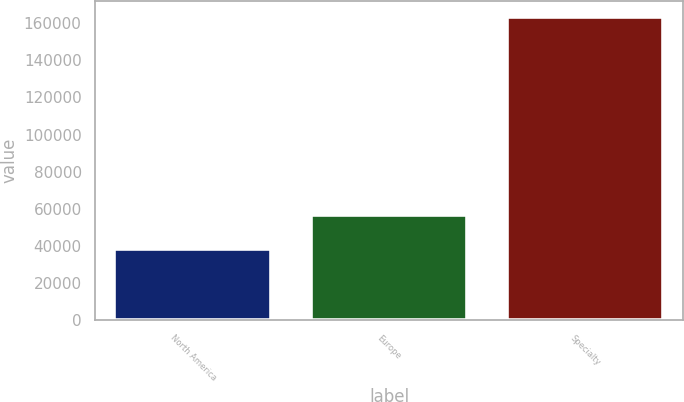Convert chart. <chart><loc_0><loc_0><loc_500><loc_500><bar_chart><fcel>North America<fcel>Europe<fcel>Specialty<nl><fcel>38100<fcel>56648<fcel>163641<nl></chart> 